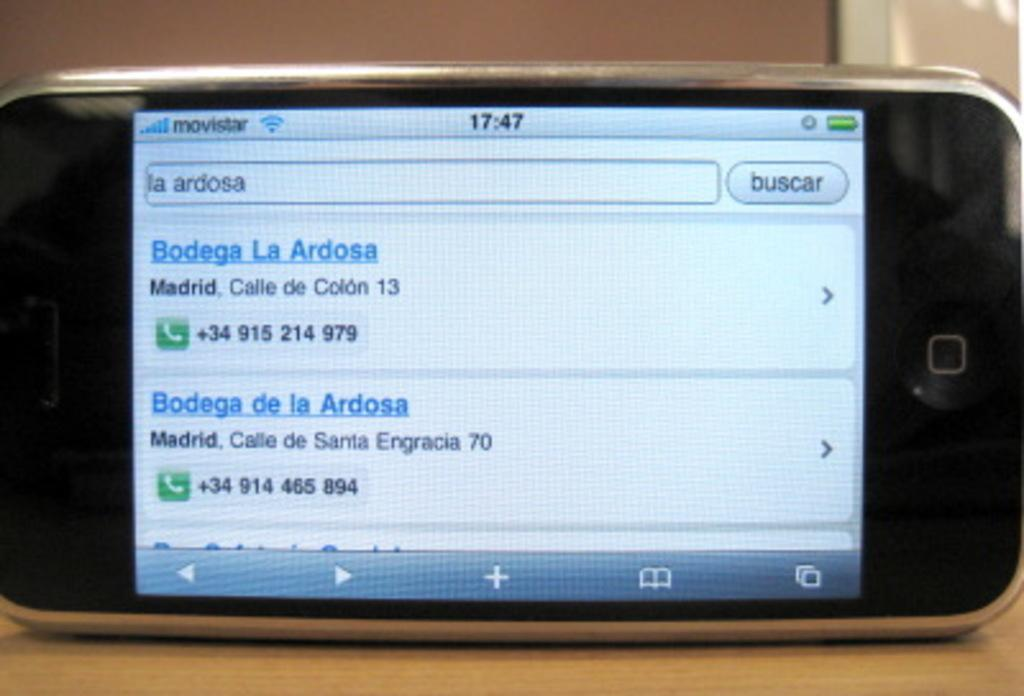<image>
Give a short and clear explanation of the subsequent image. A cellphone is showing two results for la ardosa on two different streets. 